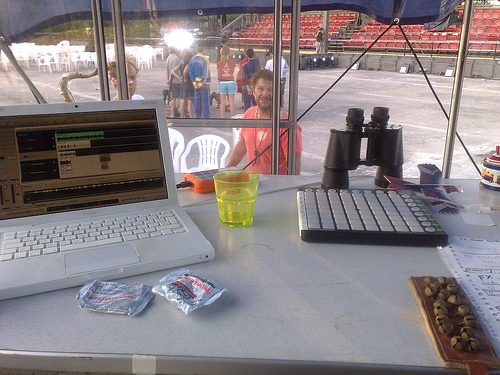<image>
Is there a chairs behind the man? Yes. From this viewpoint, the chairs is positioned behind the man, with the man partially or fully occluding the chairs. 